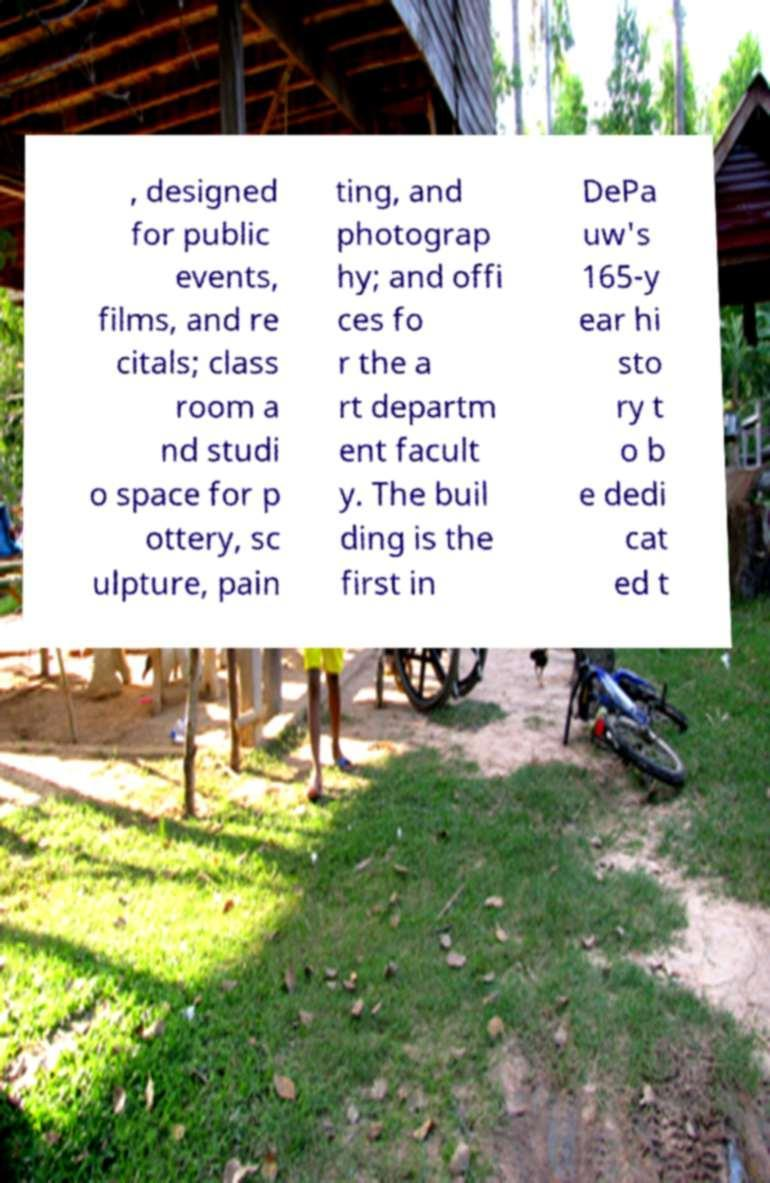Could you assist in decoding the text presented in this image and type it out clearly? , designed for public events, films, and re citals; class room a nd studi o space for p ottery, sc ulpture, pain ting, and photograp hy; and offi ces fo r the a rt departm ent facult y. The buil ding is the first in DePa uw's 165-y ear hi sto ry t o b e dedi cat ed t 